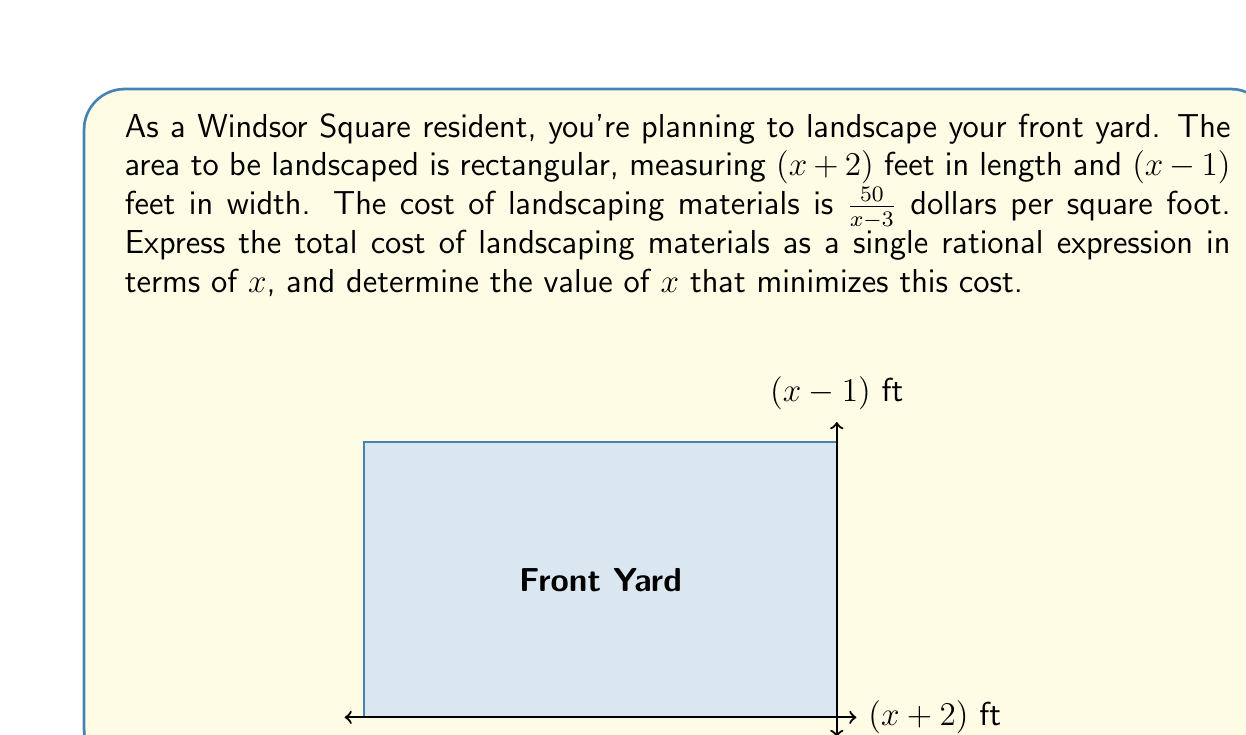Can you answer this question? Let's approach this step-by-step:

1) First, we need to find the area of the yard:
   Area = length × width
   $A = (x+2)(x-1)$
   $A = x^2 + x - 2$

2) The cost per square foot is given as $\frac{50}{x-3}$

3) To find the total cost, we multiply the area by the cost per square foot:
   Total Cost = $\frac{50}{x-3} \cdot (x^2 + x - 2)$

4) Simplifying this expression:
   $\text{Total Cost} = \frac{50(x^2 + x - 2)}{x-3}$

5) To find the value of $x$ that minimizes this cost, we need to find the critical points. In rational functions, these occur where the denominator equals zero and where the derivative equals zero.

6) The denominator is zero when $x = 3$, but this is not in the domain of our function as it would make the cost undefined.

7) To find where the derivative is zero, we would need to differentiate this complex fraction and set it to zero. However, this leads to a complex equation that's difficult to solve algebraically.

8) In practice, to find the exact minimum, we would use calculus techniques or graphing software. Without these tools, we can observe that the cost will approach infinity as $x$ approaches 3 or as $x$ becomes very large, suggesting that there is a minimum cost for some value of $x$ greater than 3.
Answer: Total Cost = $\frac{50(x^2 + x - 2)}{x-3}$; minimum occurs for $x > 3$ 